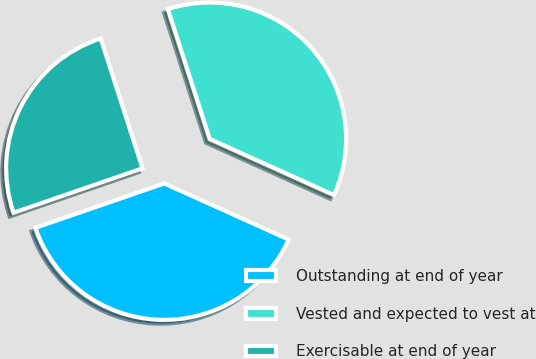<chart> <loc_0><loc_0><loc_500><loc_500><pie_chart><fcel>Outstanding at end of year<fcel>Vested and expected to vest at<fcel>Exercisable at end of year<nl><fcel>37.97%<fcel>36.71%<fcel>25.32%<nl></chart> 